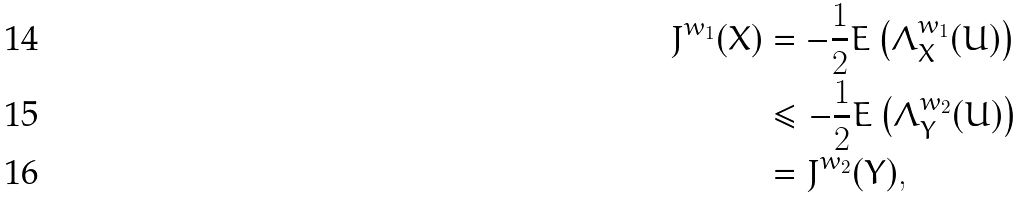<formula> <loc_0><loc_0><loc_500><loc_500>J ^ { w _ { 1 } } ( X ) & = - \frac { 1 } { 2 } E \left ( \Lambda _ { X } ^ { w _ { 1 } } ( U ) \right ) \\ & \leq - \frac { 1 } { 2 } E \left ( \Lambda _ { Y } ^ { w _ { 2 } } ( U ) \right ) \\ & = J ^ { w _ { 2 } } ( Y ) ,</formula> 